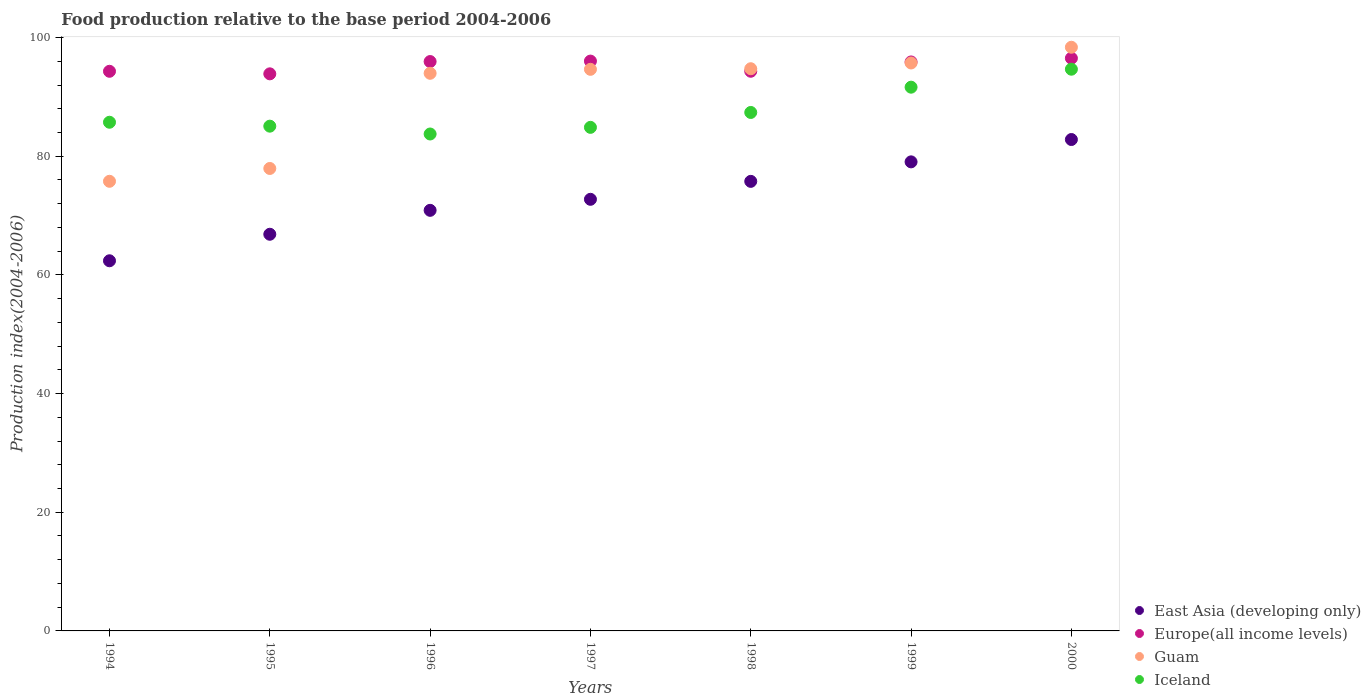Is the number of dotlines equal to the number of legend labels?
Keep it short and to the point. Yes. What is the food production index in East Asia (developing only) in 1998?
Your answer should be compact. 75.77. Across all years, what is the maximum food production index in Iceland?
Your answer should be compact. 94.67. Across all years, what is the minimum food production index in Guam?
Provide a short and direct response. 75.78. In which year was the food production index in Iceland maximum?
Give a very brief answer. 2000. In which year was the food production index in Iceland minimum?
Your response must be concise. 1996. What is the total food production index in Europe(all income levels) in the graph?
Offer a terse response. 666.94. What is the difference between the food production index in East Asia (developing only) in 1997 and that in 1999?
Keep it short and to the point. -6.31. What is the difference between the food production index in East Asia (developing only) in 1994 and the food production index in Guam in 1995?
Give a very brief answer. -15.56. What is the average food production index in Guam per year?
Your answer should be very brief. 90.17. In the year 1997, what is the difference between the food production index in Iceland and food production index in Guam?
Ensure brevity in your answer.  -9.78. In how many years, is the food production index in Guam greater than 56?
Give a very brief answer. 7. What is the ratio of the food production index in East Asia (developing only) in 1995 to that in 1998?
Offer a terse response. 0.88. What is the difference between the highest and the second highest food production index in Guam?
Provide a succinct answer. 2.65. What is the difference between the highest and the lowest food production index in East Asia (developing only)?
Make the answer very short. 20.44. Is the sum of the food production index in East Asia (developing only) in 1996 and 2000 greater than the maximum food production index in Iceland across all years?
Offer a very short reply. Yes. Is it the case that in every year, the sum of the food production index in East Asia (developing only) and food production index in Guam  is greater than the sum of food production index in Iceland and food production index in Europe(all income levels)?
Make the answer very short. No. Is it the case that in every year, the sum of the food production index in Iceland and food production index in Guam  is greater than the food production index in Europe(all income levels)?
Ensure brevity in your answer.  Yes. Is the food production index in Guam strictly greater than the food production index in Iceland over the years?
Offer a terse response. No. Is the food production index in Guam strictly less than the food production index in East Asia (developing only) over the years?
Provide a short and direct response. No. How many years are there in the graph?
Your response must be concise. 7. Does the graph contain grids?
Give a very brief answer. No. Where does the legend appear in the graph?
Provide a succinct answer. Bottom right. How many legend labels are there?
Your response must be concise. 4. How are the legend labels stacked?
Your answer should be very brief. Vertical. What is the title of the graph?
Offer a terse response. Food production relative to the base period 2004-2006. Does "French Polynesia" appear as one of the legend labels in the graph?
Provide a succinct answer. No. What is the label or title of the Y-axis?
Provide a succinct answer. Production index(2004-2006). What is the Production index(2004-2006) in East Asia (developing only) in 1994?
Make the answer very short. 62.38. What is the Production index(2004-2006) of Europe(all income levels) in 1994?
Your answer should be compact. 94.32. What is the Production index(2004-2006) in Guam in 1994?
Offer a very short reply. 75.78. What is the Production index(2004-2006) in Iceland in 1994?
Provide a short and direct response. 85.73. What is the Production index(2004-2006) of East Asia (developing only) in 1995?
Offer a very short reply. 66.85. What is the Production index(2004-2006) of Europe(all income levels) in 1995?
Ensure brevity in your answer.  93.89. What is the Production index(2004-2006) of Guam in 1995?
Ensure brevity in your answer.  77.94. What is the Production index(2004-2006) in Iceland in 1995?
Keep it short and to the point. 85.07. What is the Production index(2004-2006) in East Asia (developing only) in 1996?
Your answer should be very brief. 70.88. What is the Production index(2004-2006) of Europe(all income levels) in 1996?
Ensure brevity in your answer.  95.96. What is the Production index(2004-2006) of Guam in 1996?
Offer a very short reply. 93.98. What is the Production index(2004-2006) in Iceland in 1996?
Offer a terse response. 83.75. What is the Production index(2004-2006) of East Asia (developing only) in 1997?
Provide a short and direct response. 72.74. What is the Production index(2004-2006) of Europe(all income levels) in 1997?
Your answer should be very brief. 96.04. What is the Production index(2004-2006) in Guam in 1997?
Your answer should be very brief. 94.65. What is the Production index(2004-2006) of Iceland in 1997?
Give a very brief answer. 84.87. What is the Production index(2004-2006) of East Asia (developing only) in 1998?
Offer a very short reply. 75.77. What is the Production index(2004-2006) in Europe(all income levels) in 1998?
Provide a succinct answer. 94.32. What is the Production index(2004-2006) of Guam in 1998?
Ensure brevity in your answer.  94.75. What is the Production index(2004-2006) in Iceland in 1998?
Ensure brevity in your answer.  87.38. What is the Production index(2004-2006) of East Asia (developing only) in 1999?
Your response must be concise. 79.05. What is the Production index(2004-2006) in Europe(all income levels) in 1999?
Offer a very short reply. 95.89. What is the Production index(2004-2006) in Guam in 1999?
Make the answer very short. 95.72. What is the Production index(2004-2006) in Iceland in 1999?
Make the answer very short. 91.64. What is the Production index(2004-2006) in East Asia (developing only) in 2000?
Ensure brevity in your answer.  82.82. What is the Production index(2004-2006) of Europe(all income levels) in 2000?
Ensure brevity in your answer.  96.52. What is the Production index(2004-2006) in Guam in 2000?
Make the answer very short. 98.37. What is the Production index(2004-2006) of Iceland in 2000?
Keep it short and to the point. 94.67. Across all years, what is the maximum Production index(2004-2006) in East Asia (developing only)?
Give a very brief answer. 82.82. Across all years, what is the maximum Production index(2004-2006) in Europe(all income levels)?
Give a very brief answer. 96.52. Across all years, what is the maximum Production index(2004-2006) in Guam?
Offer a very short reply. 98.37. Across all years, what is the maximum Production index(2004-2006) of Iceland?
Offer a terse response. 94.67. Across all years, what is the minimum Production index(2004-2006) of East Asia (developing only)?
Keep it short and to the point. 62.38. Across all years, what is the minimum Production index(2004-2006) of Europe(all income levels)?
Your response must be concise. 93.89. Across all years, what is the minimum Production index(2004-2006) in Guam?
Provide a succinct answer. 75.78. Across all years, what is the minimum Production index(2004-2006) of Iceland?
Ensure brevity in your answer.  83.75. What is the total Production index(2004-2006) in East Asia (developing only) in the graph?
Provide a short and direct response. 510.5. What is the total Production index(2004-2006) of Europe(all income levels) in the graph?
Offer a very short reply. 666.94. What is the total Production index(2004-2006) in Guam in the graph?
Make the answer very short. 631.19. What is the total Production index(2004-2006) of Iceland in the graph?
Your answer should be compact. 613.11. What is the difference between the Production index(2004-2006) of East Asia (developing only) in 1994 and that in 1995?
Your answer should be compact. -4.47. What is the difference between the Production index(2004-2006) in Europe(all income levels) in 1994 and that in 1995?
Offer a terse response. 0.43. What is the difference between the Production index(2004-2006) of Guam in 1994 and that in 1995?
Offer a terse response. -2.16. What is the difference between the Production index(2004-2006) in Iceland in 1994 and that in 1995?
Keep it short and to the point. 0.66. What is the difference between the Production index(2004-2006) in East Asia (developing only) in 1994 and that in 1996?
Your answer should be compact. -8.5. What is the difference between the Production index(2004-2006) in Europe(all income levels) in 1994 and that in 1996?
Your answer should be very brief. -1.64. What is the difference between the Production index(2004-2006) in Guam in 1994 and that in 1996?
Your answer should be very brief. -18.2. What is the difference between the Production index(2004-2006) in Iceland in 1994 and that in 1996?
Your answer should be very brief. 1.98. What is the difference between the Production index(2004-2006) of East Asia (developing only) in 1994 and that in 1997?
Provide a succinct answer. -10.36. What is the difference between the Production index(2004-2006) in Europe(all income levels) in 1994 and that in 1997?
Your answer should be compact. -1.72. What is the difference between the Production index(2004-2006) in Guam in 1994 and that in 1997?
Provide a succinct answer. -18.87. What is the difference between the Production index(2004-2006) of Iceland in 1994 and that in 1997?
Provide a short and direct response. 0.86. What is the difference between the Production index(2004-2006) of East Asia (developing only) in 1994 and that in 1998?
Keep it short and to the point. -13.38. What is the difference between the Production index(2004-2006) of Europe(all income levels) in 1994 and that in 1998?
Make the answer very short. -0.01. What is the difference between the Production index(2004-2006) in Guam in 1994 and that in 1998?
Provide a short and direct response. -18.97. What is the difference between the Production index(2004-2006) of Iceland in 1994 and that in 1998?
Keep it short and to the point. -1.65. What is the difference between the Production index(2004-2006) in East Asia (developing only) in 1994 and that in 1999?
Offer a terse response. -16.67. What is the difference between the Production index(2004-2006) in Europe(all income levels) in 1994 and that in 1999?
Offer a terse response. -1.58. What is the difference between the Production index(2004-2006) of Guam in 1994 and that in 1999?
Offer a very short reply. -19.94. What is the difference between the Production index(2004-2006) of Iceland in 1994 and that in 1999?
Provide a succinct answer. -5.91. What is the difference between the Production index(2004-2006) in East Asia (developing only) in 1994 and that in 2000?
Your answer should be compact. -20.44. What is the difference between the Production index(2004-2006) in Europe(all income levels) in 1994 and that in 2000?
Your response must be concise. -2.2. What is the difference between the Production index(2004-2006) in Guam in 1994 and that in 2000?
Give a very brief answer. -22.59. What is the difference between the Production index(2004-2006) of Iceland in 1994 and that in 2000?
Provide a short and direct response. -8.94. What is the difference between the Production index(2004-2006) of East Asia (developing only) in 1995 and that in 1996?
Your answer should be compact. -4.03. What is the difference between the Production index(2004-2006) of Europe(all income levels) in 1995 and that in 1996?
Provide a short and direct response. -2.07. What is the difference between the Production index(2004-2006) in Guam in 1995 and that in 1996?
Make the answer very short. -16.04. What is the difference between the Production index(2004-2006) in Iceland in 1995 and that in 1996?
Provide a short and direct response. 1.32. What is the difference between the Production index(2004-2006) of East Asia (developing only) in 1995 and that in 1997?
Offer a terse response. -5.89. What is the difference between the Production index(2004-2006) in Europe(all income levels) in 1995 and that in 1997?
Your answer should be compact. -2.15. What is the difference between the Production index(2004-2006) of Guam in 1995 and that in 1997?
Your answer should be very brief. -16.71. What is the difference between the Production index(2004-2006) of East Asia (developing only) in 1995 and that in 1998?
Your answer should be compact. -8.91. What is the difference between the Production index(2004-2006) in Europe(all income levels) in 1995 and that in 1998?
Offer a very short reply. -0.43. What is the difference between the Production index(2004-2006) in Guam in 1995 and that in 1998?
Give a very brief answer. -16.81. What is the difference between the Production index(2004-2006) in Iceland in 1995 and that in 1998?
Offer a terse response. -2.31. What is the difference between the Production index(2004-2006) in East Asia (developing only) in 1995 and that in 1999?
Offer a terse response. -12.2. What is the difference between the Production index(2004-2006) of Europe(all income levels) in 1995 and that in 1999?
Ensure brevity in your answer.  -2. What is the difference between the Production index(2004-2006) of Guam in 1995 and that in 1999?
Your answer should be compact. -17.78. What is the difference between the Production index(2004-2006) in Iceland in 1995 and that in 1999?
Keep it short and to the point. -6.57. What is the difference between the Production index(2004-2006) in East Asia (developing only) in 1995 and that in 2000?
Keep it short and to the point. -15.97. What is the difference between the Production index(2004-2006) of Europe(all income levels) in 1995 and that in 2000?
Your response must be concise. -2.63. What is the difference between the Production index(2004-2006) in Guam in 1995 and that in 2000?
Provide a succinct answer. -20.43. What is the difference between the Production index(2004-2006) in Iceland in 1995 and that in 2000?
Your answer should be very brief. -9.6. What is the difference between the Production index(2004-2006) in East Asia (developing only) in 1996 and that in 1997?
Provide a short and direct response. -1.86. What is the difference between the Production index(2004-2006) in Europe(all income levels) in 1996 and that in 1997?
Provide a succinct answer. -0.08. What is the difference between the Production index(2004-2006) of Guam in 1996 and that in 1997?
Your response must be concise. -0.67. What is the difference between the Production index(2004-2006) in Iceland in 1996 and that in 1997?
Keep it short and to the point. -1.12. What is the difference between the Production index(2004-2006) in East Asia (developing only) in 1996 and that in 1998?
Ensure brevity in your answer.  -4.88. What is the difference between the Production index(2004-2006) of Europe(all income levels) in 1996 and that in 1998?
Your response must be concise. 1.64. What is the difference between the Production index(2004-2006) in Guam in 1996 and that in 1998?
Offer a terse response. -0.77. What is the difference between the Production index(2004-2006) of Iceland in 1996 and that in 1998?
Ensure brevity in your answer.  -3.63. What is the difference between the Production index(2004-2006) in East Asia (developing only) in 1996 and that in 1999?
Ensure brevity in your answer.  -8.17. What is the difference between the Production index(2004-2006) in Europe(all income levels) in 1996 and that in 1999?
Keep it short and to the point. 0.07. What is the difference between the Production index(2004-2006) of Guam in 1996 and that in 1999?
Make the answer very short. -1.74. What is the difference between the Production index(2004-2006) in Iceland in 1996 and that in 1999?
Provide a short and direct response. -7.89. What is the difference between the Production index(2004-2006) in East Asia (developing only) in 1996 and that in 2000?
Offer a terse response. -11.93. What is the difference between the Production index(2004-2006) of Europe(all income levels) in 1996 and that in 2000?
Keep it short and to the point. -0.56. What is the difference between the Production index(2004-2006) of Guam in 1996 and that in 2000?
Your answer should be compact. -4.39. What is the difference between the Production index(2004-2006) of Iceland in 1996 and that in 2000?
Your answer should be compact. -10.92. What is the difference between the Production index(2004-2006) in East Asia (developing only) in 1997 and that in 1998?
Offer a very short reply. -3.02. What is the difference between the Production index(2004-2006) of Europe(all income levels) in 1997 and that in 1998?
Keep it short and to the point. 1.71. What is the difference between the Production index(2004-2006) of Guam in 1997 and that in 1998?
Ensure brevity in your answer.  -0.1. What is the difference between the Production index(2004-2006) in Iceland in 1997 and that in 1998?
Your answer should be very brief. -2.51. What is the difference between the Production index(2004-2006) in East Asia (developing only) in 1997 and that in 1999?
Give a very brief answer. -6.31. What is the difference between the Production index(2004-2006) in Europe(all income levels) in 1997 and that in 1999?
Give a very brief answer. 0.14. What is the difference between the Production index(2004-2006) in Guam in 1997 and that in 1999?
Offer a very short reply. -1.07. What is the difference between the Production index(2004-2006) of Iceland in 1997 and that in 1999?
Give a very brief answer. -6.77. What is the difference between the Production index(2004-2006) of East Asia (developing only) in 1997 and that in 2000?
Your answer should be very brief. -10.08. What is the difference between the Production index(2004-2006) in Europe(all income levels) in 1997 and that in 2000?
Make the answer very short. -0.48. What is the difference between the Production index(2004-2006) in Guam in 1997 and that in 2000?
Your answer should be compact. -3.72. What is the difference between the Production index(2004-2006) in East Asia (developing only) in 1998 and that in 1999?
Your answer should be compact. -3.29. What is the difference between the Production index(2004-2006) of Europe(all income levels) in 1998 and that in 1999?
Your answer should be very brief. -1.57. What is the difference between the Production index(2004-2006) of Guam in 1998 and that in 1999?
Your response must be concise. -0.97. What is the difference between the Production index(2004-2006) of Iceland in 1998 and that in 1999?
Your answer should be compact. -4.26. What is the difference between the Production index(2004-2006) of East Asia (developing only) in 1998 and that in 2000?
Give a very brief answer. -7.05. What is the difference between the Production index(2004-2006) in Europe(all income levels) in 1998 and that in 2000?
Ensure brevity in your answer.  -2.19. What is the difference between the Production index(2004-2006) of Guam in 1998 and that in 2000?
Provide a succinct answer. -3.62. What is the difference between the Production index(2004-2006) in Iceland in 1998 and that in 2000?
Offer a terse response. -7.29. What is the difference between the Production index(2004-2006) in East Asia (developing only) in 1999 and that in 2000?
Your response must be concise. -3.77. What is the difference between the Production index(2004-2006) of Europe(all income levels) in 1999 and that in 2000?
Your answer should be compact. -0.62. What is the difference between the Production index(2004-2006) of Guam in 1999 and that in 2000?
Make the answer very short. -2.65. What is the difference between the Production index(2004-2006) of Iceland in 1999 and that in 2000?
Give a very brief answer. -3.03. What is the difference between the Production index(2004-2006) in East Asia (developing only) in 1994 and the Production index(2004-2006) in Europe(all income levels) in 1995?
Your response must be concise. -31.51. What is the difference between the Production index(2004-2006) in East Asia (developing only) in 1994 and the Production index(2004-2006) in Guam in 1995?
Offer a terse response. -15.56. What is the difference between the Production index(2004-2006) of East Asia (developing only) in 1994 and the Production index(2004-2006) of Iceland in 1995?
Give a very brief answer. -22.69. What is the difference between the Production index(2004-2006) of Europe(all income levels) in 1994 and the Production index(2004-2006) of Guam in 1995?
Offer a very short reply. 16.38. What is the difference between the Production index(2004-2006) of Europe(all income levels) in 1994 and the Production index(2004-2006) of Iceland in 1995?
Provide a succinct answer. 9.25. What is the difference between the Production index(2004-2006) in Guam in 1994 and the Production index(2004-2006) in Iceland in 1995?
Offer a very short reply. -9.29. What is the difference between the Production index(2004-2006) in East Asia (developing only) in 1994 and the Production index(2004-2006) in Europe(all income levels) in 1996?
Offer a terse response. -33.58. What is the difference between the Production index(2004-2006) of East Asia (developing only) in 1994 and the Production index(2004-2006) of Guam in 1996?
Your answer should be very brief. -31.6. What is the difference between the Production index(2004-2006) in East Asia (developing only) in 1994 and the Production index(2004-2006) in Iceland in 1996?
Offer a terse response. -21.37. What is the difference between the Production index(2004-2006) in Europe(all income levels) in 1994 and the Production index(2004-2006) in Guam in 1996?
Provide a succinct answer. 0.34. What is the difference between the Production index(2004-2006) of Europe(all income levels) in 1994 and the Production index(2004-2006) of Iceland in 1996?
Your answer should be very brief. 10.57. What is the difference between the Production index(2004-2006) of Guam in 1994 and the Production index(2004-2006) of Iceland in 1996?
Offer a very short reply. -7.97. What is the difference between the Production index(2004-2006) in East Asia (developing only) in 1994 and the Production index(2004-2006) in Europe(all income levels) in 1997?
Keep it short and to the point. -33.65. What is the difference between the Production index(2004-2006) of East Asia (developing only) in 1994 and the Production index(2004-2006) of Guam in 1997?
Offer a terse response. -32.27. What is the difference between the Production index(2004-2006) of East Asia (developing only) in 1994 and the Production index(2004-2006) of Iceland in 1997?
Ensure brevity in your answer.  -22.49. What is the difference between the Production index(2004-2006) in Europe(all income levels) in 1994 and the Production index(2004-2006) in Guam in 1997?
Make the answer very short. -0.33. What is the difference between the Production index(2004-2006) in Europe(all income levels) in 1994 and the Production index(2004-2006) in Iceland in 1997?
Your response must be concise. 9.45. What is the difference between the Production index(2004-2006) of Guam in 1994 and the Production index(2004-2006) of Iceland in 1997?
Your answer should be very brief. -9.09. What is the difference between the Production index(2004-2006) of East Asia (developing only) in 1994 and the Production index(2004-2006) of Europe(all income levels) in 1998?
Your answer should be very brief. -31.94. What is the difference between the Production index(2004-2006) of East Asia (developing only) in 1994 and the Production index(2004-2006) of Guam in 1998?
Make the answer very short. -32.37. What is the difference between the Production index(2004-2006) in East Asia (developing only) in 1994 and the Production index(2004-2006) in Iceland in 1998?
Offer a terse response. -25. What is the difference between the Production index(2004-2006) in Europe(all income levels) in 1994 and the Production index(2004-2006) in Guam in 1998?
Offer a very short reply. -0.43. What is the difference between the Production index(2004-2006) of Europe(all income levels) in 1994 and the Production index(2004-2006) of Iceland in 1998?
Make the answer very short. 6.94. What is the difference between the Production index(2004-2006) in Guam in 1994 and the Production index(2004-2006) in Iceland in 1998?
Keep it short and to the point. -11.6. What is the difference between the Production index(2004-2006) of East Asia (developing only) in 1994 and the Production index(2004-2006) of Europe(all income levels) in 1999?
Provide a short and direct response. -33.51. What is the difference between the Production index(2004-2006) of East Asia (developing only) in 1994 and the Production index(2004-2006) of Guam in 1999?
Provide a succinct answer. -33.34. What is the difference between the Production index(2004-2006) in East Asia (developing only) in 1994 and the Production index(2004-2006) in Iceland in 1999?
Your answer should be very brief. -29.26. What is the difference between the Production index(2004-2006) of Europe(all income levels) in 1994 and the Production index(2004-2006) of Guam in 1999?
Give a very brief answer. -1.4. What is the difference between the Production index(2004-2006) in Europe(all income levels) in 1994 and the Production index(2004-2006) in Iceland in 1999?
Your response must be concise. 2.68. What is the difference between the Production index(2004-2006) of Guam in 1994 and the Production index(2004-2006) of Iceland in 1999?
Make the answer very short. -15.86. What is the difference between the Production index(2004-2006) in East Asia (developing only) in 1994 and the Production index(2004-2006) in Europe(all income levels) in 2000?
Give a very brief answer. -34.14. What is the difference between the Production index(2004-2006) of East Asia (developing only) in 1994 and the Production index(2004-2006) of Guam in 2000?
Offer a terse response. -35.99. What is the difference between the Production index(2004-2006) in East Asia (developing only) in 1994 and the Production index(2004-2006) in Iceland in 2000?
Your response must be concise. -32.29. What is the difference between the Production index(2004-2006) of Europe(all income levels) in 1994 and the Production index(2004-2006) of Guam in 2000?
Make the answer very short. -4.05. What is the difference between the Production index(2004-2006) of Europe(all income levels) in 1994 and the Production index(2004-2006) of Iceland in 2000?
Make the answer very short. -0.35. What is the difference between the Production index(2004-2006) of Guam in 1994 and the Production index(2004-2006) of Iceland in 2000?
Offer a very short reply. -18.89. What is the difference between the Production index(2004-2006) in East Asia (developing only) in 1995 and the Production index(2004-2006) in Europe(all income levels) in 1996?
Your response must be concise. -29.11. What is the difference between the Production index(2004-2006) of East Asia (developing only) in 1995 and the Production index(2004-2006) of Guam in 1996?
Offer a terse response. -27.13. What is the difference between the Production index(2004-2006) of East Asia (developing only) in 1995 and the Production index(2004-2006) of Iceland in 1996?
Give a very brief answer. -16.9. What is the difference between the Production index(2004-2006) of Europe(all income levels) in 1995 and the Production index(2004-2006) of Guam in 1996?
Make the answer very short. -0.09. What is the difference between the Production index(2004-2006) in Europe(all income levels) in 1995 and the Production index(2004-2006) in Iceland in 1996?
Ensure brevity in your answer.  10.14. What is the difference between the Production index(2004-2006) in Guam in 1995 and the Production index(2004-2006) in Iceland in 1996?
Provide a short and direct response. -5.81. What is the difference between the Production index(2004-2006) of East Asia (developing only) in 1995 and the Production index(2004-2006) of Europe(all income levels) in 1997?
Offer a terse response. -29.19. What is the difference between the Production index(2004-2006) of East Asia (developing only) in 1995 and the Production index(2004-2006) of Guam in 1997?
Give a very brief answer. -27.8. What is the difference between the Production index(2004-2006) in East Asia (developing only) in 1995 and the Production index(2004-2006) in Iceland in 1997?
Make the answer very short. -18.02. What is the difference between the Production index(2004-2006) of Europe(all income levels) in 1995 and the Production index(2004-2006) of Guam in 1997?
Ensure brevity in your answer.  -0.76. What is the difference between the Production index(2004-2006) of Europe(all income levels) in 1995 and the Production index(2004-2006) of Iceland in 1997?
Your answer should be very brief. 9.02. What is the difference between the Production index(2004-2006) in Guam in 1995 and the Production index(2004-2006) in Iceland in 1997?
Your answer should be compact. -6.93. What is the difference between the Production index(2004-2006) in East Asia (developing only) in 1995 and the Production index(2004-2006) in Europe(all income levels) in 1998?
Your answer should be very brief. -27.47. What is the difference between the Production index(2004-2006) in East Asia (developing only) in 1995 and the Production index(2004-2006) in Guam in 1998?
Make the answer very short. -27.9. What is the difference between the Production index(2004-2006) of East Asia (developing only) in 1995 and the Production index(2004-2006) of Iceland in 1998?
Your answer should be compact. -20.53. What is the difference between the Production index(2004-2006) in Europe(all income levels) in 1995 and the Production index(2004-2006) in Guam in 1998?
Keep it short and to the point. -0.86. What is the difference between the Production index(2004-2006) of Europe(all income levels) in 1995 and the Production index(2004-2006) of Iceland in 1998?
Offer a terse response. 6.51. What is the difference between the Production index(2004-2006) in Guam in 1995 and the Production index(2004-2006) in Iceland in 1998?
Your answer should be very brief. -9.44. What is the difference between the Production index(2004-2006) in East Asia (developing only) in 1995 and the Production index(2004-2006) in Europe(all income levels) in 1999?
Provide a succinct answer. -29.04. What is the difference between the Production index(2004-2006) of East Asia (developing only) in 1995 and the Production index(2004-2006) of Guam in 1999?
Offer a very short reply. -28.87. What is the difference between the Production index(2004-2006) in East Asia (developing only) in 1995 and the Production index(2004-2006) in Iceland in 1999?
Offer a very short reply. -24.79. What is the difference between the Production index(2004-2006) of Europe(all income levels) in 1995 and the Production index(2004-2006) of Guam in 1999?
Keep it short and to the point. -1.83. What is the difference between the Production index(2004-2006) of Europe(all income levels) in 1995 and the Production index(2004-2006) of Iceland in 1999?
Your response must be concise. 2.25. What is the difference between the Production index(2004-2006) in Guam in 1995 and the Production index(2004-2006) in Iceland in 1999?
Keep it short and to the point. -13.7. What is the difference between the Production index(2004-2006) of East Asia (developing only) in 1995 and the Production index(2004-2006) of Europe(all income levels) in 2000?
Offer a terse response. -29.67. What is the difference between the Production index(2004-2006) of East Asia (developing only) in 1995 and the Production index(2004-2006) of Guam in 2000?
Provide a succinct answer. -31.52. What is the difference between the Production index(2004-2006) of East Asia (developing only) in 1995 and the Production index(2004-2006) of Iceland in 2000?
Your response must be concise. -27.82. What is the difference between the Production index(2004-2006) of Europe(all income levels) in 1995 and the Production index(2004-2006) of Guam in 2000?
Keep it short and to the point. -4.48. What is the difference between the Production index(2004-2006) in Europe(all income levels) in 1995 and the Production index(2004-2006) in Iceland in 2000?
Make the answer very short. -0.78. What is the difference between the Production index(2004-2006) in Guam in 1995 and the Production index(2004-2006) in Iceland in 2000?
Give a very brief answer. -16.73. What is the difference between the Production index(2004-2006) in East Asia (developing only) in 1996 and the Production index(2004-2006) in Europe(all income levels) in 1997?
Your answer should be compact. -25.15. What is the difference between the Production index(2004-2006) in East Asia (developing only) in 1996 and the Production index(2004-2006) in Guam in 1997?
Keep it short and to the point. -23.77. What is the difference between the Production index(2004-2006) of East Asia (developing only) in 1996 and the Production index(2004-2006) of Iceland in 1997?
Provide a succinct answer. -13.98. What is the difference between the Production index(2004-2006) of Europe(all income levels) in 1996 and the Production index(2004-2006) of Guam in 1997?
Your answer should be very brief. 1.31. What is the difference between the Production index(2004-2006) in Europe(all income levels) in 1996 and the Production index(2004-2006) in Iceland in 1997?
Your answer should be compact. 11.09. What is the difference between the Production index(2004-2006) in Guam in 1996 and the Production index(2004-2006) in Iceland in 1997?
Provide a short and direct response. 9.11. What is the difference between the Production index(2004-2006) in East Asia (developing only) in 1996 and the Production index(2004-2006) in Europe(all income levels) in 1998?
Provide a short and direct response. -23.44. What is the difference between the Production index(2004-2006) of East Asia (developing only) in 1996 and the Production index(2004-2006) of Guam in 1998?
Offer a very short reply. -23.86. What is the difference between the Production index(2004-2006) of East Asia (developing only) in 1996 and the Production index(2004-2006) of Iceland in 1998?
Your answer should be very brief. -16.5. What is the difference between the Production index(2004-2006) in Europe(all income levels) in 1996 and the Production index(2004-2006) in Guam in 1998?
Give a very brief answer. 1.21. What is the difference between the Production index(2004-2006) of Europe(all income levels) in 1996 and the Production index(2004-2006) of Iceland in 1998?
Your answer should be very brief. 8.58. What is the difference between the Production index(2004-2006) in Guam in 1996 and the Production index(2004-2006) in Iceland in 1998?
Provide a succinct answer. 6.6. What is the difference between the Production index(2004-2006) in East Asia (developing only) in 1996 and the Production index(2004-2006) in Europe(all income levels) in 1999?
Your answer should be very brief. -25.01. What is the difference between the Production index(2004-2006) of East Asia (developing only) in 1996 and the Production index(2004-2006) of Guam in 1999?
Give a very brief answer. -24.84. What is the difference between the Production index(2004-2006) in East Asia (developing only) in 1996 and the Production index(2004-2006) in Iceland in 1999?
Provide a succinct answer. -20.75. What is the difference between the Production index(2004-2006) in Europe(all income levels) in 1996 and the Production index(2004-2006) in Guam in 1999?
Your answer should be compact. 0.24. What is the difference between the Production index(2004-2006) in Europe(all income levels) in 1996 and the Production index(2004-2006) in Iceland in 1999?
Provide a short and direct response. 4.32. What is the difference between the Production index(2004-2006) of Guam in 1996 and the Production index(2004-2006) of Iceland in 1999?
Your response must be concise. 2.34. What is the difference between the Production index(2004-2006) in East Asia (developing only) in 1996 and the Production index(2004-2006) in Europe(all income levels) in 2000?
Give a very brief answer. -25.63. What is the difference between the Production index(2004-2006) of East Asia (developing only) in 1996 and the Production index(2004-2006) of Guam in 2000?
Give a very brief answer. -27.48. What is the difference between the Production index(2004-2006) in East Asia (developing only) in 1996 and the Production index(2004-2006) in Iceland in 2000?
Give a very brief answer. -23.79. What is the difference between the Production index(2004-2006) of Europe(all income levels) in 1996 and the Production index(2004-2006) of Guam in 2000?
Your answer should be very brief. -2.41. What is the difference between the Production index(2004-2006) in Europe(all income levels) in 1996 and the Production index(2004-2006) in Iceland in 2000?
Keep it short and to the point. 1.29. What is the difference between the Production index(2004-2006) in Guam in 1996 and the Production index(2004-2006) in Iceland in 2000?
Offer a terse response. -0.69. What is the difference between the Production index(2004-2006) of East Asia (developing only) in 1997 and the Production index(2004-2006) of Europe(all income levels) in 1998?
Provide a succinct answer. -21.58. What is the difference between the Production index(2004-2006) of East Asia (developing only) in 1997 and the Production index(2004-2006) of Guam in 1998?
Give a very brief answer. -22.01. What is the difference between the Production index(2004-2006) in East Asia (developing only) in 1997 and the Production index(2004-2006) in Iceland in 1998?
Make the answer very short. -14.64. What is the difference between the Production index(2004-2006) in Europe(all income levels) in 1997 and the Production index(2004-2006) in Guam in 1998?
Your answer should be compact. 1.29. What is the difference between the Production index(2004-2006) of Europe(all income levels) in 1997 and the Production index(2004-2006) of Iceland in 1998?
Provide a short and direct response. 8.66. What is the difference between the Production index(2004-2006) of Guam in 1997 and the Production index(2004-2006) of Iceland in 1998?
Offer a terse response. 7.27. What is the difference between the Production index(2004-2006) in East Asia (developing only) in 1997 and the Production index(2004-2006) in Europe(all income levels) in 1999?
Provide a short and direct response. -23.15. What is the difference between the Production index(2004-2006) in East Asia (developing only) in 1997 and the Production index(2004-2006) in Guam in 1999?
Your answer should be very brief. -22.98. What is the difference between the Production index(2004-2006) in East Asia (developing only) in 1997 and the Production index(2004-2006) in Iceland in 1999?
Your response must be concise. -18.9. What is the difference between the Production index(2004-2006) of Europe(all income levels) in 1997 and the Production index(2004-2006) of Guam in 1999?
Your response must be concise. 0.32. What is the difference between the Production index(2004-2006) in Europe(all income levels) in 1997 and the Production index(2004-2006) in Iceland in 1999?
Make the answer very short. 4.4. What is the difference between the Production index(2004-2006) in Guam in 1997 and the Production index(2004-2006) in Iceland in 1999?
Provide a succinct answer. 3.01. What is the difference between the Production index(2004-2006) in East Asia (developing only) in 1997 and the Production index(2004-2006) in Europe(all income levels) in 2000?
Give a very brief answer. -23.78. What is the difference between the Production index(2004-2006) in East Asia (developing only) in 1997 and the Production index(2004-2006) in Guam in 2000?
Your answer should be very brief. -25.63. What is the difference between the Production index(2004-2006) of East Asia (developing only) in 1997 and the Production index(2004-2006) of Iceland in 2000?
Your answer should be compact. -21.93. What is the difference between the Production index(2004-2006) of Europe(all income levels) in 1997 and the Production index(2004-2006) of Guam in 2000?
Provide a succinct answer. -2.33. What is the difference between the Production index(2004-2006) of Europe(all income levels) in 1997 and the Production index(2004-2006) of Iceland in 2000?
Provide a short and direct response. 1.37. What is the difference between the Production index(2004-2006) of Guam in 1997 and the Production index(2004-2006) of Iceland in 2000?
Your answer should be very brief. -0.02. What is the difference between the Production index(2004-2006) in East Asia (developing only) in 1998 and the Production index(2004-2006) in Europe(all income levels) in 1999?
Make the answer very short. -20.13. What is the difference between the Production index(2004-2006) in East Asia (developing only) in 1998 and the Production index(2004-2006) in Guam in 1999?
Keep it short and to the point. -19.95. What is the difference between the Production index(2004-2006) in East Asia (developing only) in 1998 and the Production index(2004-2006) in Iceland in 1999?
Your response must be concise. -15.87. What is the difference between the Production index(2004-2006) in Europe(all income levels) in 1998 and the Production index(2004-2006) in Guam in 1999?
Provide a succinct answer. -1.4. What is the difference between the Production index(2004-2006) in Europe(all income levels) in 1998 and the Production index(2004-2006) in Iceland in 1999?
Make the answer very short. 2.68. What is the difference between the Production index(2004-2006) in Guam in 1998 and the Production index(2004-2006) in Iceland in 1999?
Keep it short and to the point. 3.11. What is the difference between the Production index(2004-2006) of East Asia (developing only) in 1998 and the Production index(2004-2006) of Europe(all income levels) in 2000?
Keep it short and to the point. -20.75. What is the difference between the Production index(2004-2006) of East Asia (developing only) in 1998 and the Production index(2004-2006) of Guam in 2000?
Your answer should be very brief. -22.6. What is the difference between the Production index(2004-2006) of East Asia (developing only) in 1998 and the Production index(2004-2006) of Iceland in 2000?
Provide a short and direct response. -18.9. What is the difference between the Production index(2004-2006) of Europe(all income levels) in 1998 and the Production index(2004-2006) of Guam in 2000?
Your answer should be very brief. -4.05. What is the difference between the Production index(2004-2006) of Europe(all income levels) in 1998 and the Production index(2004-2006) of Iceland in 2000?
Ensure brevity in your answer.  -0.35. What is the difference between the Production index(2004-2006) of East Asia (developing only) in 1999 and the Production index(2004-2006) of Europe(all income levels) in 2000?
Offer a very short reply. -17.46. What is the difference between the Production index(2004-2006) in East Asia (developing only) in 1999 and the Production index(2004-2006) in Guam in 2000?
Ensure brevity in your answer.  -19.32. What is the difference between the Production index(2004-2006) in East Asia (developing only) in 1999 and the Production index(2004-2006) in Iceland in 2000?
Your answer should be compact. -15.62. What is the difference between the Production index(2004-2006) of Europe(all income levels) in 1999 and the Production index(2004-2006) of Guam in 2000?
Keep it short and to the point. -2.48. What is the difference between the Production index(2004-2006) in Europe(all income levels) in 1999 and the Production index(2004-2006) in Iceland in 2000?
Give a very brief answer. 1.22. What is the average Production index(2004-2006) in East Asia (developing only) per year?
Provide a succinct answer. 72.93. What is the average Production index(2004-2006) in Europe(all income levels) per year?
Offer a very short reply. 95.28. What is the average Production index(2004-2006) of Guam per year?
Ensure brevity in your answer.  90.17. What is the average Production index(2004-2006) in Iceland per year?
Your answer should be very brief. 87.59. In the year 1994, what is the difference between the Production index(2004-2006) of East Asia (developing only) and Production index(2004-2006) of Europe(all income levels)?
Provide a short and direct response. -31.94. In the year 1994, what is the difference between the Production index(2004-2006) in East Asia (developing only) and Production index(2004-2006) in Guam?
Your answer should be compact. -13.4. In the year 1994, what is the difference between the Production index(2004-2006) in East Asia (developing only) and Production index(2004-2006) in Iceland?
Your answer should be very brief. -23.35. In the year 1994, what is the difference between the Production index(2004-2006) in Europe(all income levels) and Production index(2004-2006) in Guam?
Keep it short and to the point. 18.54. In the year 1994, what is the difference between the Production index(2004-2006) in Europe(all income levels) and Production index(2004-2006) in Iceland?
Provide a short and direct response. 8.59. In the year 1994, what is the difference between the Production index(2004-2006) in Guam and Production index(2004-2006) in Iceland?
Ensure brevity in your answer.  -9.95. In the year 1995, what is the difference between the Production index(2004-2006) of East Asia (developing only) and Production index(2004-2006) of Europe(all income levels)?
Give a very brief answer. -27.04. In the year 1995, what is the difference between the Production index(2004-2006) of East Asia (developing only) and Production index(2004-2006) of Guam?
Provide a succinct answer. -11.09. In the year 1995, what is the difference between the Production index(2004-2006) in East Asia (developing only) and Production index(2004-2006) in Iceland?
Your answer should be compact. -18.22. In the year 1995, what is the difference between the Production index(2004-2006) of Europe(all income levels) and Production index(2004-2006) of Guam?
Provide a succinct answer. 15.95. In the year 1995, what is the difference between the Production index(2004-2006) of Europe(all income levels) and Production index(2004-2006) of Iceland?
Your response must be concise. 8.82. In the year 1995, what is the difference between the Production index(2004-2006) of Guam and Production index(2004-2006) of Iceland?
Your response must be concise. -7.13. In the year 1996, what is the difference between the Production index(2004-2006) of East Asia (developing only) and Production index(2004-2006) of Europe(all income levels)?
Offer a very short reply. -25.07. In the year 1996, what is the difference between the Production index(2004-2006) in East Asia (developing only) and Production index(2004-2006) in Guam?
Provide a short and direct response. -23.09. In the year 1996, what is the difference between the Production index(2004-2006) in East Asia (developing only) and Production index(2004-2006) in Iceland?
Your response must be concise. -12.87. In the year 1996, what is the difference between the Production index(2004-2006) in Europe(all income levels) and Production index(2004-2006) in Guam?
Offer a very short reply. 1.98. In the year 1996, what is the difference between the Production index(2004-2006) of Europe(all income levels) and Production index(2004-2006) of Iceland?
Offer a terse response. 12.21. In the year 1996, what is the difference between the Production index(2004-2006) in Guam and Production index(2004-2006) in Iceland?
Provide a succinct answer. 10.23. In the year 1997, what is the difference between the Production index(2004-2006) in East Asia (developing only) and Production index(2004-2006) in Europe(all income levels)?
Ensure brevity in your answer.  -23.29. In the year 1997, what is the difference between the Production index(2004-2006) of East Asia (developing only) and Production index(2004-2006) of Guam?
Make the answer very short. -21.91. In the year 1997, what is the difference between the Production index(2004-2006) in East Asia (developing only) and Production index(2004-2006) in Iceland?
Your answer should be very brief. -12.13. In the year 1997, what is the difference between the Production index(2004-2006) of Europe(all income levels) and Production index(2004-2006) of Guam?
Your answer should be very brief. 1.39. In the year 1997, what is the difference between the Production index(2004-2006) of Europe(all income levels) and Production index(2004-2006) of Iceland?
Your answer should be very brief. 11.17. In the year 1997, what is the difference between the Production index(2004-2006) in Guam and Production index(2004-2006) in Iceland?
Make the answer very short. 9.78. In the year 1998, what is the difference between the Production index(2004-2006) of East Asia (developing only) and Production index(2004-2006) of Europe(all income levels)?
Give a very brief answer. -18.56. In the year 1998, what is the difference between the Production index(2004-2006) of East Asia (developing only) and Production index(2004-2006) of Guam?
Ensure brevity in your answer.  -18.98. In the year 1998, what is the difference between the Production index(2004-2006) of East Asia (developing only) and Production index(2004-2006) of Iceland?
Your response must be concise. -11.61. In the year 1998, what is the difference between the Production index(2004-2006) of Europe(all income levels) and Production index(2004-2006) of Guam?
Offer a terse response. -0.43. In the year 1998, what is the difference between the Production index(2004-2006) of Europe(all income levels) and Production index(2004-2006) of Iceland?
Ensure brevity in your answer.  6.94. In the year 1998, what is the difference between the Production index(2004-2006) of Guam and Production index(2004-2006) of Iceland?
Your answer should be compact. 7.37. In the year 1999, what is the difference between the Production index(2004-2006) in East Asia (developing only) and Production index(2004-2006) in Europe(all income levels)?
Give a very brief answer. -16.84. In the year 1999, what is the difference between the Production index(2004-2006) in East Asia (developing only) and Production index(2004-2006) in Guam?
Offer a very short reply. -16.67. In the year 1999, what is the difference between the Production index(2004-2006) in East Asia (developing only) and Production index(2004-2006) in Iceland?
Give a very brief answer. -12.59. In the year 1999, what is the difference between the Production index(2004-2006) in Europe(all income levels) and Production index(2004-2006) in Guam?
Offer a terse response. 0.17. In the year 1999, what is the difference between the Production index(2004-2006) of Europe(all income levels) and Production index(2004-2006) of Iceland?
Provide a succinct answer. 4.25. In the year 1999, what is the difference between the Production index(2004-2006) of Guam and Production index(2004-2006) of Iceland?
Provide a succinct answer. 4.08. In the year 2000, what is the difference between the Production index(2004-2006) in East Asia (developing only) and Production index(2004-2006) in Europe(all income levels)?
Your answer should be compact. -13.7. In the year 2000, what is the difference between the Production index(2004-2006) in East Asia (developing only) and Production index(2004-2006) in Guam?
Give a very brief answer. -15.55. In the year 2000, what is the difference between the Production index(2004-2006) in East Asia (developing only) and Production index(2004-2006) in Iceland?
Make the answer very short. -11.85. In the year 2000, what is the difference between the Production index(2004-2006) of Europe(all income levels) and Production index(2004-2006) of Guam?
Make the answer very short. -1.85. In the year 2000, what is the difference between the Production index(2004-2006) of Europe(all income levels) and Production index(2004-2006) of Iceland?
Offer a terse response. 1.85. What is the ratio of the Production index(2004-2006) of East Asia (developing only) in 1994 to that in 1995?
Your answer should be compact. 0.93. What is the ratio of the Production index(2004-2006) of Europe(all income levels) in 1994 to that in 1995?
Provide a succinct answer. 1. What is the ratio of the Production index(2004-2006) in Guam in 1994 to that in 1995?
Offer a very short reply. 0.97. What is the ratio of the Production index(2004-2006) in Iceland in 1994 to that in 1995?
Provide a short and direct response. 1.01. What is the ratio of the Production index(2004-2006) in East Asia (developing only) in 1994 to that in 1996?
Offer a terse response. 0.88. What is the ratio of the Production index(2004-2006) of Europe(all income levels) in 1994 to that in 1996?
Make the answer very short. 0.98. What is the ratio of the Production index(2004-2006) of Guam in 1994 to that in 1996?
Your answer should be very brief. 0.81. What is the ratio of the Production index(2004-2006) in Iceland in 1994 to that in 1996?
Ensure brevity in your answer.  1.02. What is the ratio of the Production index(2004-2006) of East Asia (developing only) in 1994 to that in 1997?
Offer a very short reply. 0.86. What is the ratio of the Production index(2004-2006) in Europe(all income levels) in 1994 to that in 1997?
Provide a succinct answer. 0.98. What is the ratio of the Production index(2004-2006) in Guam in 1994 to that in 1997?
Your response must be concise. 0.8. What is the ratio of the Production index(2004-2006) in East Asia (developing only) in 1994 to that in 1998?
Give a very brief answer. 0.82. What is the ratio of the Production index(2004-2006) of Europe(all income levels) in 1994 to that in 1998?
Your response must be concise. 1. What is the ratio of the Production index(2004-2006) of Guam in 1994 to that in 1998?
Your response must be concise. 0.8. What is the ratio of the Production index(2004-2006) in Iceland in 1994 to that in 1998?
Offer a terse response. 0.98. What is the ratio of the Production index(2004-2006) of East Asia (developing only) in 1994 to that in 1999?
Give a very brief answer. 0.79. What is the ratio of the Production index(2004-2006) of Europe(all income levels) in 1994 to that in 1999?
Ensure brevity in your answer.  0.98. What is the ratio of the Production index(2004-2006) of Guam in 1994 to that in 1999?
Offer a terse response. 0.79. What is the ratio of the Production index(2004-2006) in Iceland in 1994 to that in 1999?
Make the answer very short. 0.94. What is the ratio of the Production index(2004-2006) in East Asia (developing only) in 1994 to that in 2000?
Keep it short and to the point. 0.75. What is the ratio of the Production index(2004-2006) in Europe(all income levels) in 1994 to that in 2000?
Ensure brevity in your answer.  0.98. What is the ratio of the Production index(2004-2006) of Guam in 1994 to that in 2000?
Your answer should be compact. 0.77. What is the ratio of the Production index(2004-2006) of Iceland in 1994 to that in 2000?
Offer a terse response. 0.91. What is the ratio of the Production index(2004-2006) of East Asia (developing only) in 1995 to that in 1996?
Keep it short and to the point. 0.94. What is the ratio of the Production index(2004-2006) in Europe(all income levels) in 1995 to that in 1996?
Keep it short and to the point. 0.98. What is the ratio of the Production index(2004-2006) of Guam in 1995 to that in 1996?
Your answer should be very brief. 0.83. What is the ratio of the Production index(2004-2006) in Iceland in 1995 to that in 1996?
Your answer should be very brief. 1.02. What is the ratio of the Production index(2004-2006) in East Asia (developing only) in 1995 to that in 1997?
Provide a succinct answer. 0.92. What is the ratio of the Production index(2004-2006) of Europe(all income levels) in 1995 to that in 1997?
Your answer should be very brief. 0.98. What is the ratio of the Production index(2004-2006) in Guam in 1995 to that in 1997?
Make the answer very short. 0.82. What is the ratio of the Production index(2004-2006) in East Asia (developing only) in 1995 to that in 1998?
Provide a short and direct response. 0.88. What is the ratio of the Production index(2004-2006) of Europe(all income levels) in 1995 to that in 1998?
Give a very brief answer. 1. What is the ratio of the Production index(2004-2006) of Guam in 1995 to that in 1998?
Provide a short and direct response. 0.82. What is the ratio of the Production index(2004-2006) in Iceland in 1995 to that in 1998?
Make the answer very short. 0.97. What is the ratio of the Production index(2004-2006) in East Asia (developing only) in 1995 to that in 1999?
Provide a short and direct response. 0.85. What is the ratio of the Production index(2004-2006) in Europe(all income levels) in 1995 to that in 1999?
Your answer should be very brief. 0.98. What is the ratio of the Production index(2004-2006) of Guam in 1995 to that in 1999?
Keep it short and to the point. 0.81. What is the ratio of the Production index(2004-2006) in Iceland in 1995 to that in 1999?
Provide a succinct answer. 0.93. What is the ratio of the Production index(2004-2006) of East Asia (developing only) in 1995 to that in 2000?
Your response must be concise. 0.81. What is the ratio of the Production index(2004-2006) in Europe(all income levels) in 1995 to that in 2000?
Ensure brevity in your answer.  0.97. What is the ratio of the Production index(2004-2006) of Guam in 1995 to that in 2000?
Make the answer very short. 0.79. What is the ratio of the Production index(2004-2006) of Iceland in 1995 to that in 2000?
Provide a short and direct response. 0.9. What is the ratio of the Production index(2004-2006) of East Asia (developing only) in 1996 to that in 1997?
Keep it short and to the point. 0.97. What is the ratio of the Production index(2004-2006) of Europe(all income levels) in 1996 to that in 1997?
Your response must be concise. 1. What is the ratio of the Production index(2004-2006) in East Asia (developing only) in 1996 to that in 1998?
Your answer should be compact. 0.94. What is the ratio of the Production index(2004-2006) of Europe(all income levels) in 1996 to that in 1998?
Your answer should be very brief. 1.02. What is the ratio of the Production index(2004-2006) of Guam in 1996 to that in 1998?
Your answer should be compact. 0.99. What is the ratio of the Production index(2004-2006) in Iceland in 1996 to that in 1998?
Give a very brief answer. 0.96. What is the ratio of the Production index(2004-2006) of East Asia (developing only) in 1996 to that in 1999?
Provide a succinct answer. 0.9. What is the ratio of the Production index(2004-2006) of Europe(all income levels) in 1996 to that in 1999?
Keep it short and to the point. 1. What is the ratio of the Production index(2004-2006) in Guam in 1996 to that in 1999?
Your response must be concise. 0.98. What is the ratio of the Production index(2004-2006) in Iceland in 1996 to that in 1999?
Provide a succinct answer. 0.91. What is the ratio of the Production index(2004-2006) of East Asia (developing only) in 1996 to that in 2000?
Offer a terse response. 0.86. What is the ratio of the Production index(2004-2006) of Guam in 1996 to that in 2000?
Your response must be concise. 0.96. What is the ratio of the Production index(2004-2006) of Iceland in 1996 to that in 2000?
Make the answer very short. 0.88. What is the ratio of the Production index(2004-2006) of East Asia (developing only) in 1997 to that in 1998?
Provide a succinct answer. 0.96. What is the ratio of the Production index(2004-2006) of Europe(all income levels) in 1997 to that in 1998?
Your answer should be very brief. 1.02. What is the ratio of the Production index(2004-2006) in Iceland in 1997 to that in 1998?
Keep it short and to the point. 0.97. What is the ratio of the Production index(2004-2006) of East Asia (developing only) in 1997 to that in 1999?
Offer a very short reply. 0.92. What is the ratio of the Production index(2004-2006) of Guam in 1997 to that in 1999?
Keep it short and to the point. 0.99. What is the ratio of the Production index(2004-2006) in Iceland in 1997 to that in 1999?
Keep it short and to the point. 0.93. What is the ratio of the Production index(2004-2006) in East Asia (developing only) in 1997 to that in 2000?
Your response must be concise. 0.88. What is the ratio of the Production index(2004-2006) in Europe(all income levels) in 1997 to that in 2000?
Give a very brief answer. 0.99. What is the ratio of the Production index(2004-2006) of Guam in 1997 to that in 2000?
Provide a short and direct response. 0.96. What is the ratio of the Production index(2004-2006) of Iceland in 1997 to that in 2000?
Your response must be concise. 0.9. What is the ratio of the Production index(2004-2006) in East Asia (developing only) in 1998 to that in 1999?
Offer a terse response. 0.96. What is the ratio of the Production index(2004-2006) in Europe(all income levels) in 1998 to that in 1999?
Ensure brevity in your answer.  0.98. What is the ratio of the Production index(2004-2006) of Guam in 1998 to that in 1999?
Offer a very short reply. 0.99. What is the ratio of the Production index(2004-2006) of Iceland in 1998 to that in 1999?
Give a very brief answer. 0.95. What is the ratio of the Production index(2004-2006) of East Asia (developing only) in 1998 to that in 2000?
Keep it short and to the point. 0.91. What is the ratio of the Production index(2004-2006) in Europe(all income levels) in 1998 to that in 2000?
Provide a succinct answer. 0.98. What is the ratio of the Production index(2004-2006) of Guam in 1998 to that in 2000?
Ensure brevity in your answer.  0.96. What is the ratio of the Production index(2004-2006) in Iceland in 1998 to that in 2000?
Provide a succinct answer. 0.92. What is the ratio of the Production index(2004-2006) of East Asia (developing only) in 1999 to that in 2000?
Make the answer very short. 0.95. What is the ratio of the Production index(2004-2006) in Europe(all income levels) in 1999 to that in 2000?
Make the answer very short. 0.99. What is the ratio of the Production index(2004-2006) in Guam in 1999 to that in 2000?
Give a very brief answer. 0.97. What is the difference between the highest and the second highest Production index(2004-2006) in East Asia (developing only)?
Provide a short and direct response. 3.77. What is the difference between the highest and the second highest Production index(2004-2006) of Europe(all income levels)?
Provide a succinct answer. 0.48. What is the difference between the highest and the second highest Production index(2004-2006) of Guam?
Keep it short and to the point. 2.65. What is the difference between the highest and the second highest Production index(2004-2006) in Iceland?
Keep it short and to the point. 3.03. What is the difference between the highest and the lowest Production index(2004-2006) in East Asia (developing only)?
Keep it short and to the point. 20.44. What is the difference between the highest and the lowest Production index(2004-2006) of Europe(all income levels)?
Your response must be concise. 2.63. What is the difference between the highest and the lowest Production index(2004-2006) of Guam?
Provide a succinct answer. 22.59. What is the difference between the highest and the lowest Production index(2004-2006) in Iceland?
Provide a short and direct response. 10.92. 